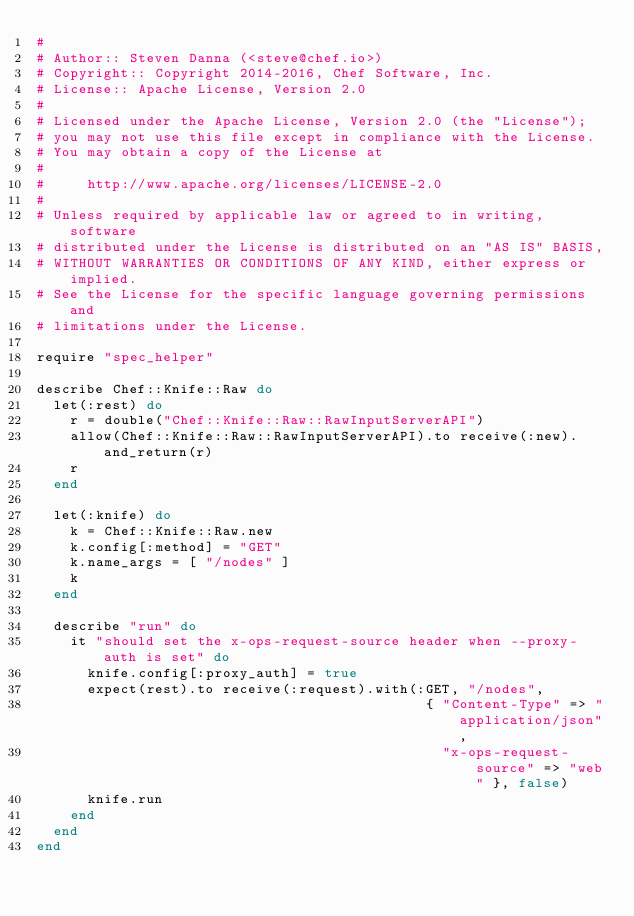<code> <loc_0><loc_0><loc_500><loc_500><_Ruby_>#
# Author:: Steven Danna (<steve@chef.io>)
# Copyright:: Copyright 2014-2016, Chef Software, Inc.
# License:: Apache License, Version 2.0
#
# Licensed under the Apache License, Version 2.0 (the "License");
# you may not use this file except in compliance with the License.
# You may obtain a copy of the License at
#
#     http://www.apache.org/licenses/LICENSE-2.0
#
# Unless required by applicable law or agreed to in writing, software
# distributed under the License is distributed on an "AS IS" BASIS,
# WITHOUT WARRANTIES OR CONDITIONS OF ANY KIND, either express or implied.
# See the License for the specific language governing permissions and
# limitations under the License.

require "spec_helper"

describe Chef::Knife::Raw do
  let(:rest) do
    r = double("Chef::Knife::Raw::RawInputServerAPI")
    allow(Chef::Knife::Raw::RawInputServerAPI).to receive(:new).and_return(r)
    r
  end

  let(:knife) do
    k = Chef::Knife::Raw.new
    k.config[:method] = "GET"
    k.name_args = [ "/nodes" ]
    k
  end

  describe "run" do
    it "should set the x-ops-request-source header when --proxy-auth is set" do
      knife.config[:proxy_auth] = true
      expect(rest).to receive(:request).with(:GET, "/nodes",
                                              { "Content-Type" => "application/json",
                                                "x-ops-request-source" => "web" }, false)
      knife.run
    end
  end
end
</code> 